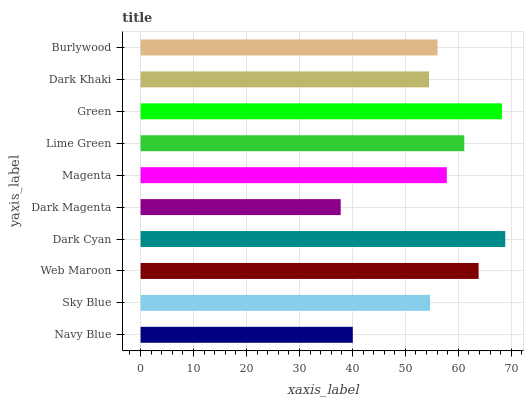Is Dark Magenta the minimum?
Answer yes or no. Yes. Is Dark Cyan the maximum?
Answer yes or no. Yes. Is Sky Blue the minimum?
Answer yes or no. No. Is Sky Blue the maximum?
Answer yes or no. No. Is Sky Blue greater than Navy Blue?
Answer yes or no. Yes. Is Navy Blue less than Sky Blue?
Answer yes or no. Yes. Is Navy Blue greater than Sky Blue?
Answer yes or no. No. Is Sky Blue less than Navy Blue?
Answer yes or no. No. Is Magenta the high median?
Answer yes or no. Yes. Is Burlywood the low median?
Answer yes or no. Yes. Is Burlywood the high median?
Answer yes or no. No. Is Green the low median?
Answer yes or no. No. 